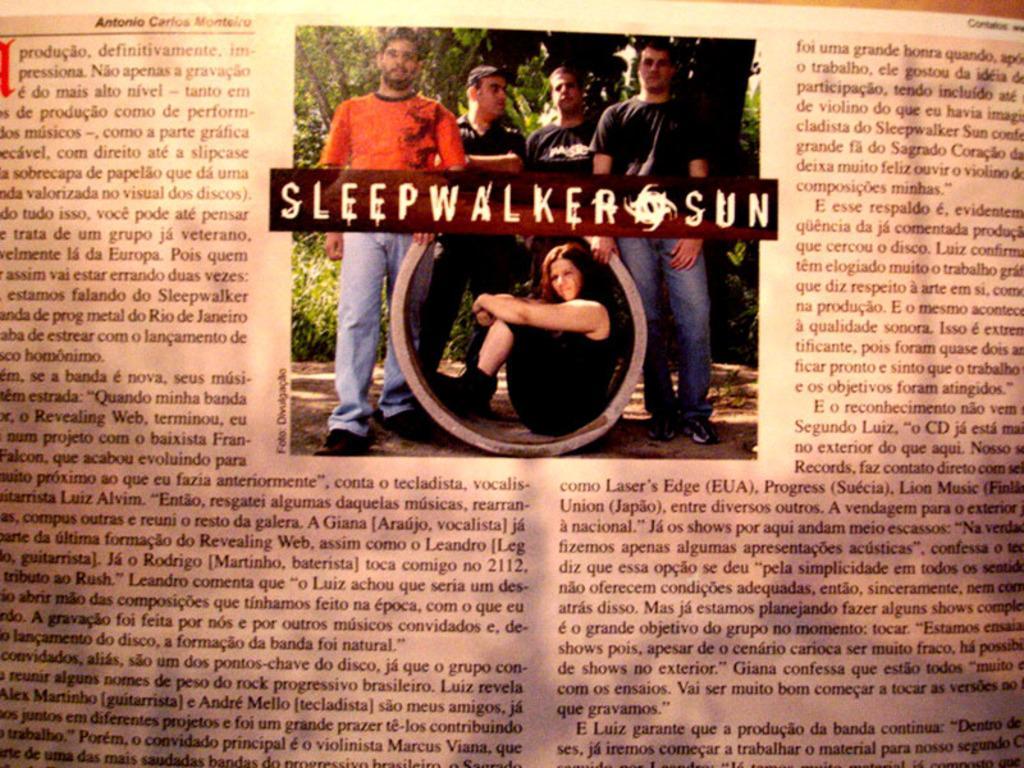Please provide a concise description of this image. In this image there is one news paper, and on the paper there is text and in the center of the paper there are some persons standing and one woman is sitting in a cement pipe. And in the background there are some trees. 